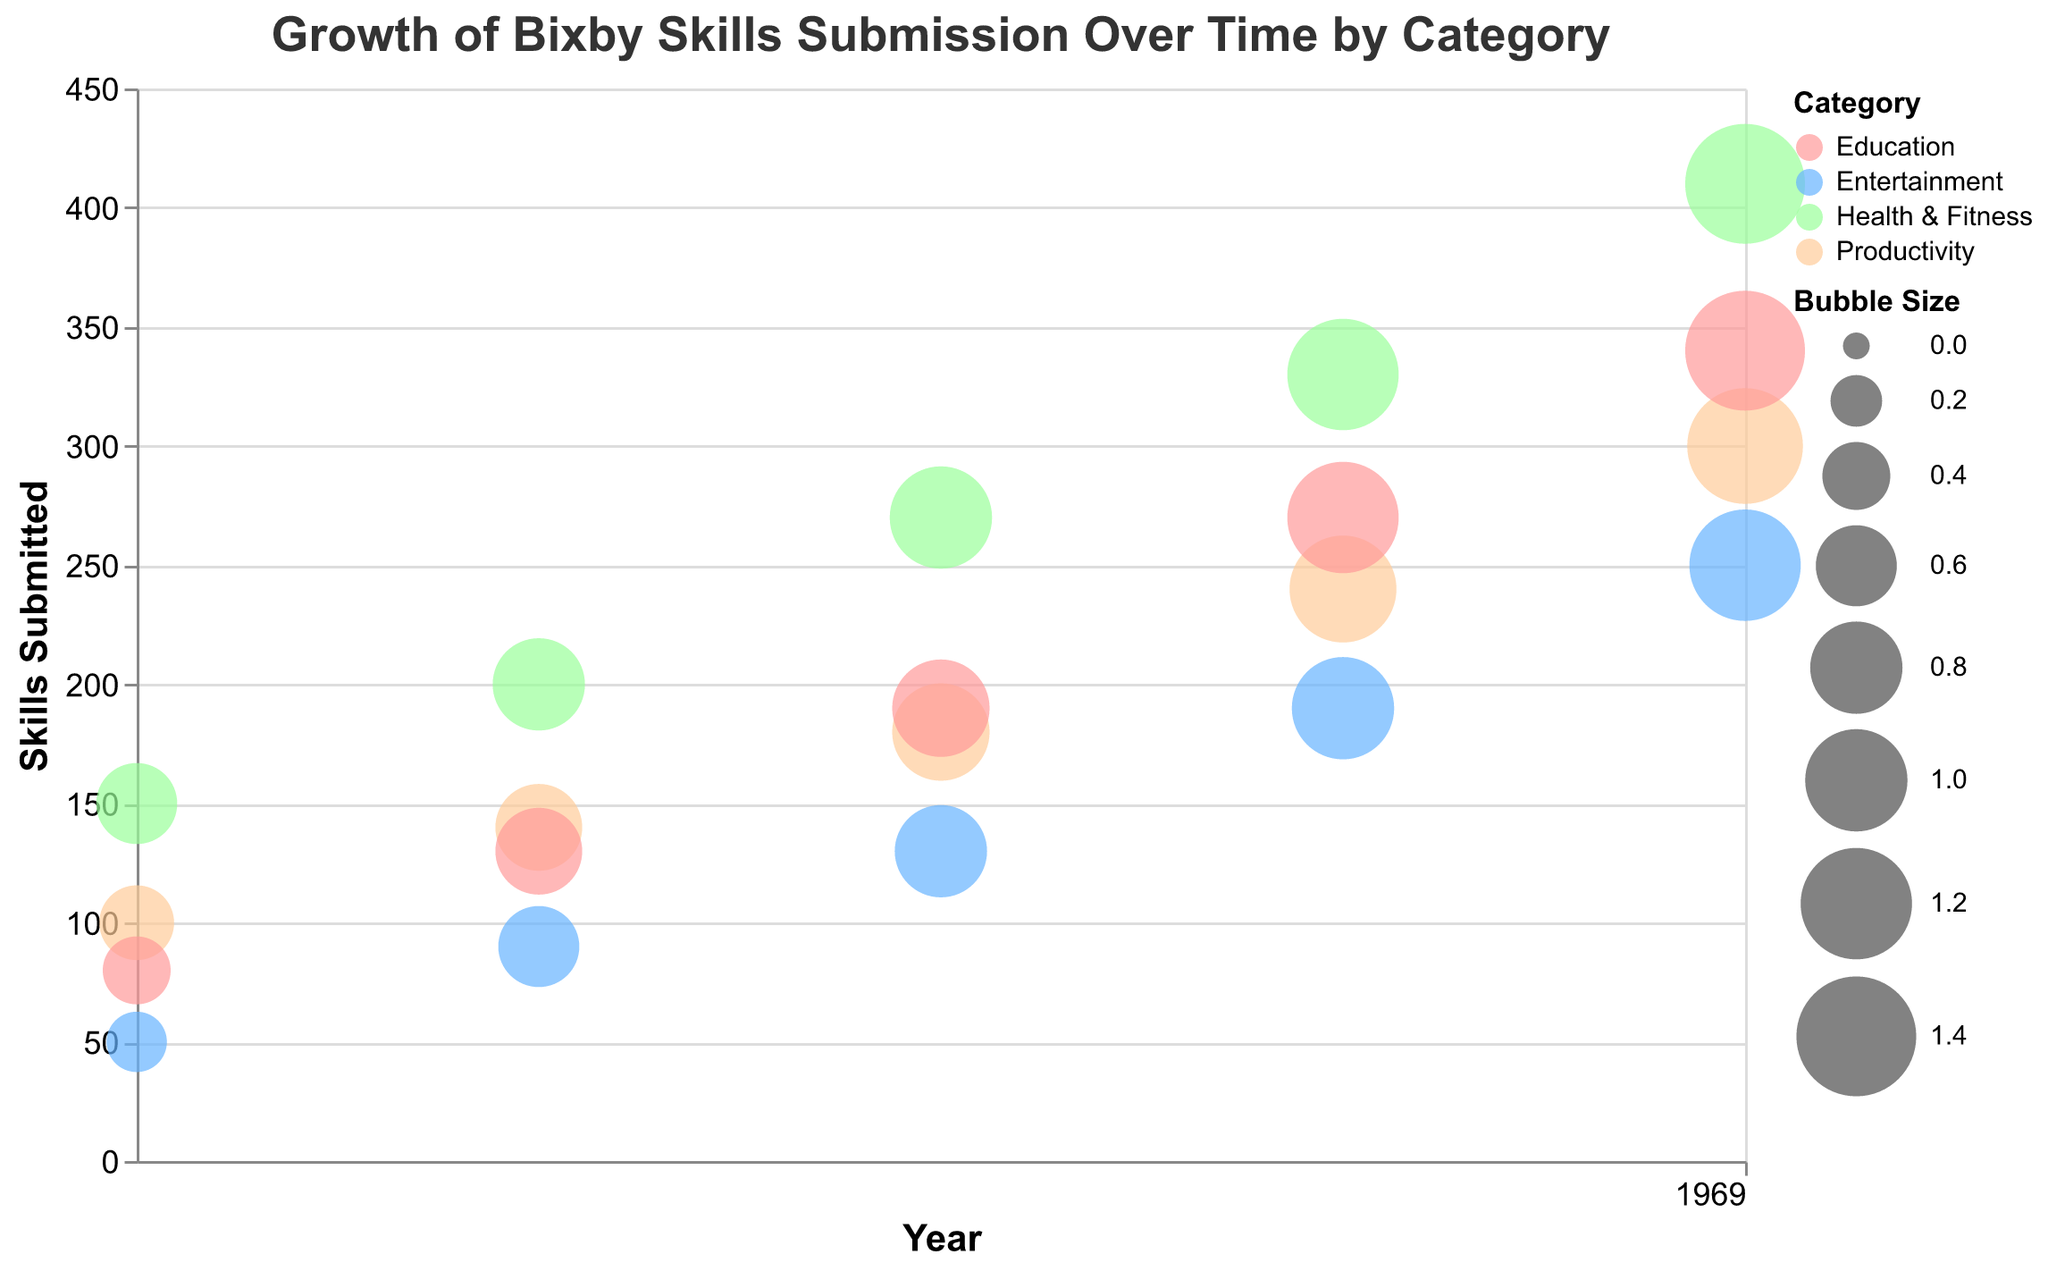What's the title of the chart? The title is displayed at the top of the chart as "Growth of Bixby Skills Submission Over Time by Category".
Answer: Growth of Bixby Skills Submission Over Time by Category What two categories had the largest bubble sizes in 2022? Look at the size of the bubbles for each category in the year 2022. The largest bubbles in 2022 correspond to Health & Fitness and Education categories.
Answer: Health & Fitness and Education Which category had the highest growth rate in 2019? Check the tooltip information or the y-axis values for the growth rate in 2019. The Entertainment category had a growth rate of 80, which is the highest.
Answer: Entertainment How many skills were submitted in the Productivity category in 2021? Search for the bubbles representing Productivity in 2021 and refer to the tooltip or y-axis values for "Skills Submitted". There were 240 skills submitted.
Answer: 240 What is the color used to represent the Education category? Identify the color used for the bubbles in the Education category; it is a shade of light green.
Answer: light green Calculate the total number of skills submitted for the Health & Fitness category over all years. Sum the "Skills Submitted" values for the Health & Fitness category from 2018 to 2022: 150 + 200 + 270 + 330 + 410 = 1360.
Answer: 1360 Compare the trend of the Growth Rate for the Education category vs. the Entertainment category from 2018 to 2022. Which category had more consistent growth? Analyze the change in growth rates over the years for both categories. Education's growth rates are relatively consistent (20, 63, 46, 42, 26), while Entertainment had a sharp increase and fluctuated more (10, 80, 44, 46, 32). Thus, Education had more consistent growth.
Answer: Education Identify which year had the smallest number of skills submitted across all categories. Look at the y-axis intersection for the smallest bubble across all categories and years. The smallest number of skills submitted across all categories occurred in 2018 for Entertainment (50 skills).
Answer: 2018 How does the size of bubbles correspond to the skills submitted and growth rate? Refer to the chart to understand bubble size correlation. Bubbles are sized according to the "Bubble Size" attribute, which correlates with a combination of "Skills Submitted" and "Growth Rate". Larger bubbles often indicate more skills submitted and potentially higher growth rates.
Answer: By a combination of skills submitted and growth rate 